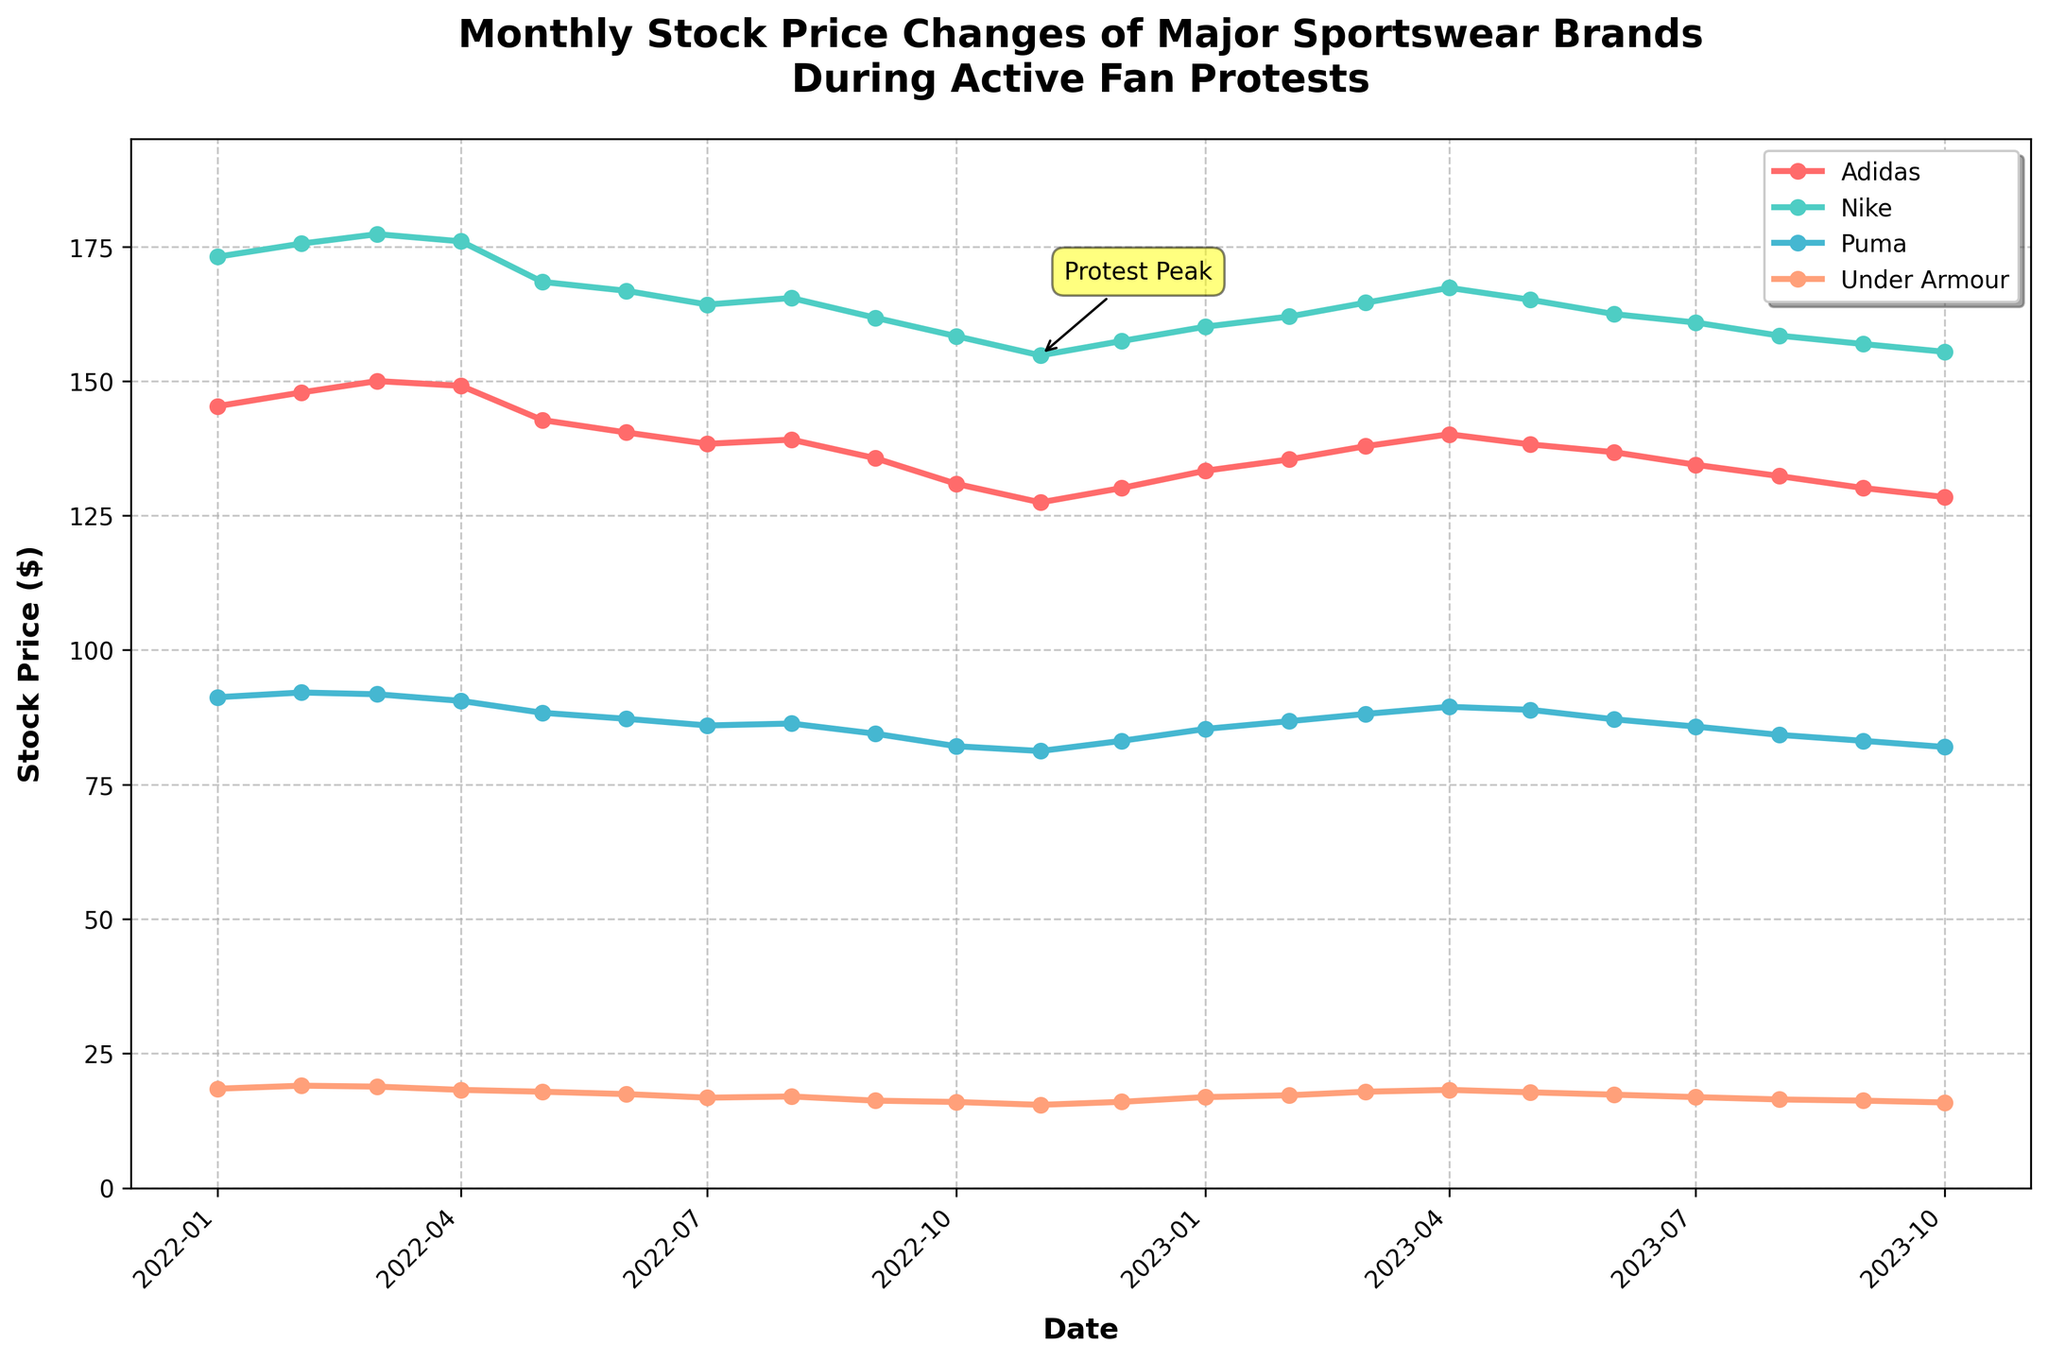What's the title of the plot? The title of the plot is derived directly from the top text of the figure.
Answer: Monthly Stock Price Changes of Major Sportswear Brands During Active Fan Protests What brands are included in the plot? Look at the legend or the labels in the plot. The brands are clearly indicated there.
Answer: Adidas, Nike, Puma, Under Armour Which brand had the highest stock price in January 2022? Locate the starting date on the x-axis corresponding to January 2022 and compare the y-axis values for each brand.
Answer: Nike How did Adidas's stock price change from January 2022 to October 2022? Look for the stock price values of Adidas in January 2022 and October 2022, then calculate the difference.
Answer: Decreased by approximately $14.45 What was the trend for Nike's stock price over the 22-month period? Observe the line plot for Nike from the start to the end of the period and describe the overall direction and significant fluctuations.
Answer: Generally decreasing with minor fluctuations When did Puma have its lowest stock price, and what was the value? Find the lowest point on the Puma line plot and note the associated date and y-axis value.
Answer: October 2022, around $82.12 How does the stock price of Under Armour in January 2023 compare to its stock price in January 2022? Locate the values for Under Armour for January of both years and compare them directly.
Answer: It is higher in January 2023 Which month marks the 'Protest Peak' according to the annotation on the figure? Look for the annotation on the plot and identify the corresponding month.
Answer: November 2022 Calculate the average stock price of all brands in December 2022. Add all stock prices for December 2022 and divide by the number of brands (4). (130.12+157.45+83.12+16.01)/4 = 386.7/4
Answer: 96.68 Between February 2023 and May 2023, which brand showed the most consistent stock price trend? Examine the plot lines for each brand within the specified dates and identify the brand with the least fluctuation.
Answer: Puma 